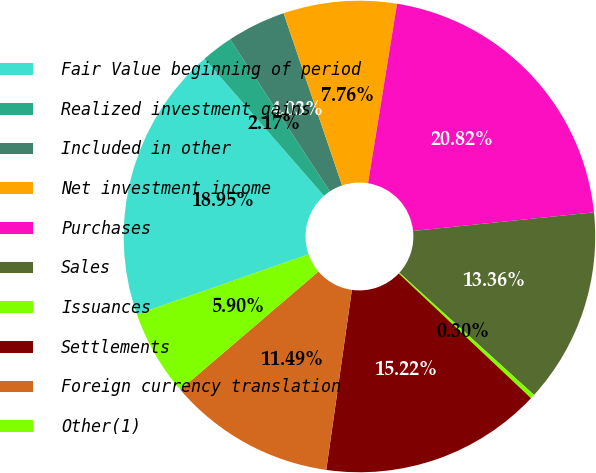Convert chart to OTSL. <chart><loc_0><loc_0><loc_500><loc_500><pie_chart><fcel>Fair Value beginning of period<fcel>Realized investment gains<fcel>Included in other<fcel>Net investment income<fcel>Purchases<fcel>Sales<fcel>Issuances<fcel>Settlements<fcel>Foreign currency translation<fcel>Other(1)<nl><fcel>18.95%<fcel>2.17%<fcel>4.03%<fcel>7.76%<fcel>20.82%<fcel>13.36%<fcel>0.3%<fcel>15.22%<fcel>11.49%<fcel>5.9%<nl></chart> 